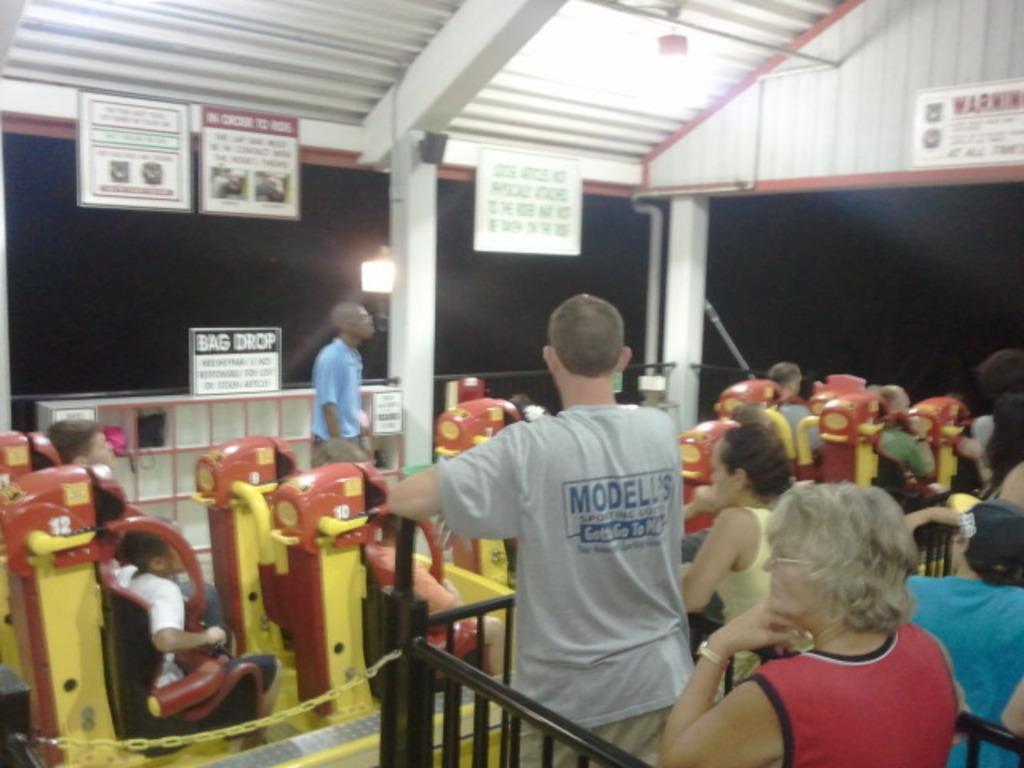Please provide a concise description of this image. In front of the image on the right side there are few people standing. In front of them there is railing and also there is an iron chain. Behind them there are few people sitting inside the amusement park ride. Behind them there is a man. And also there is a railing with a poster and some text on it. At the top of the image there is a ceiling with lights, pillars, sign boards and poles. And there is a dark background with a light. 